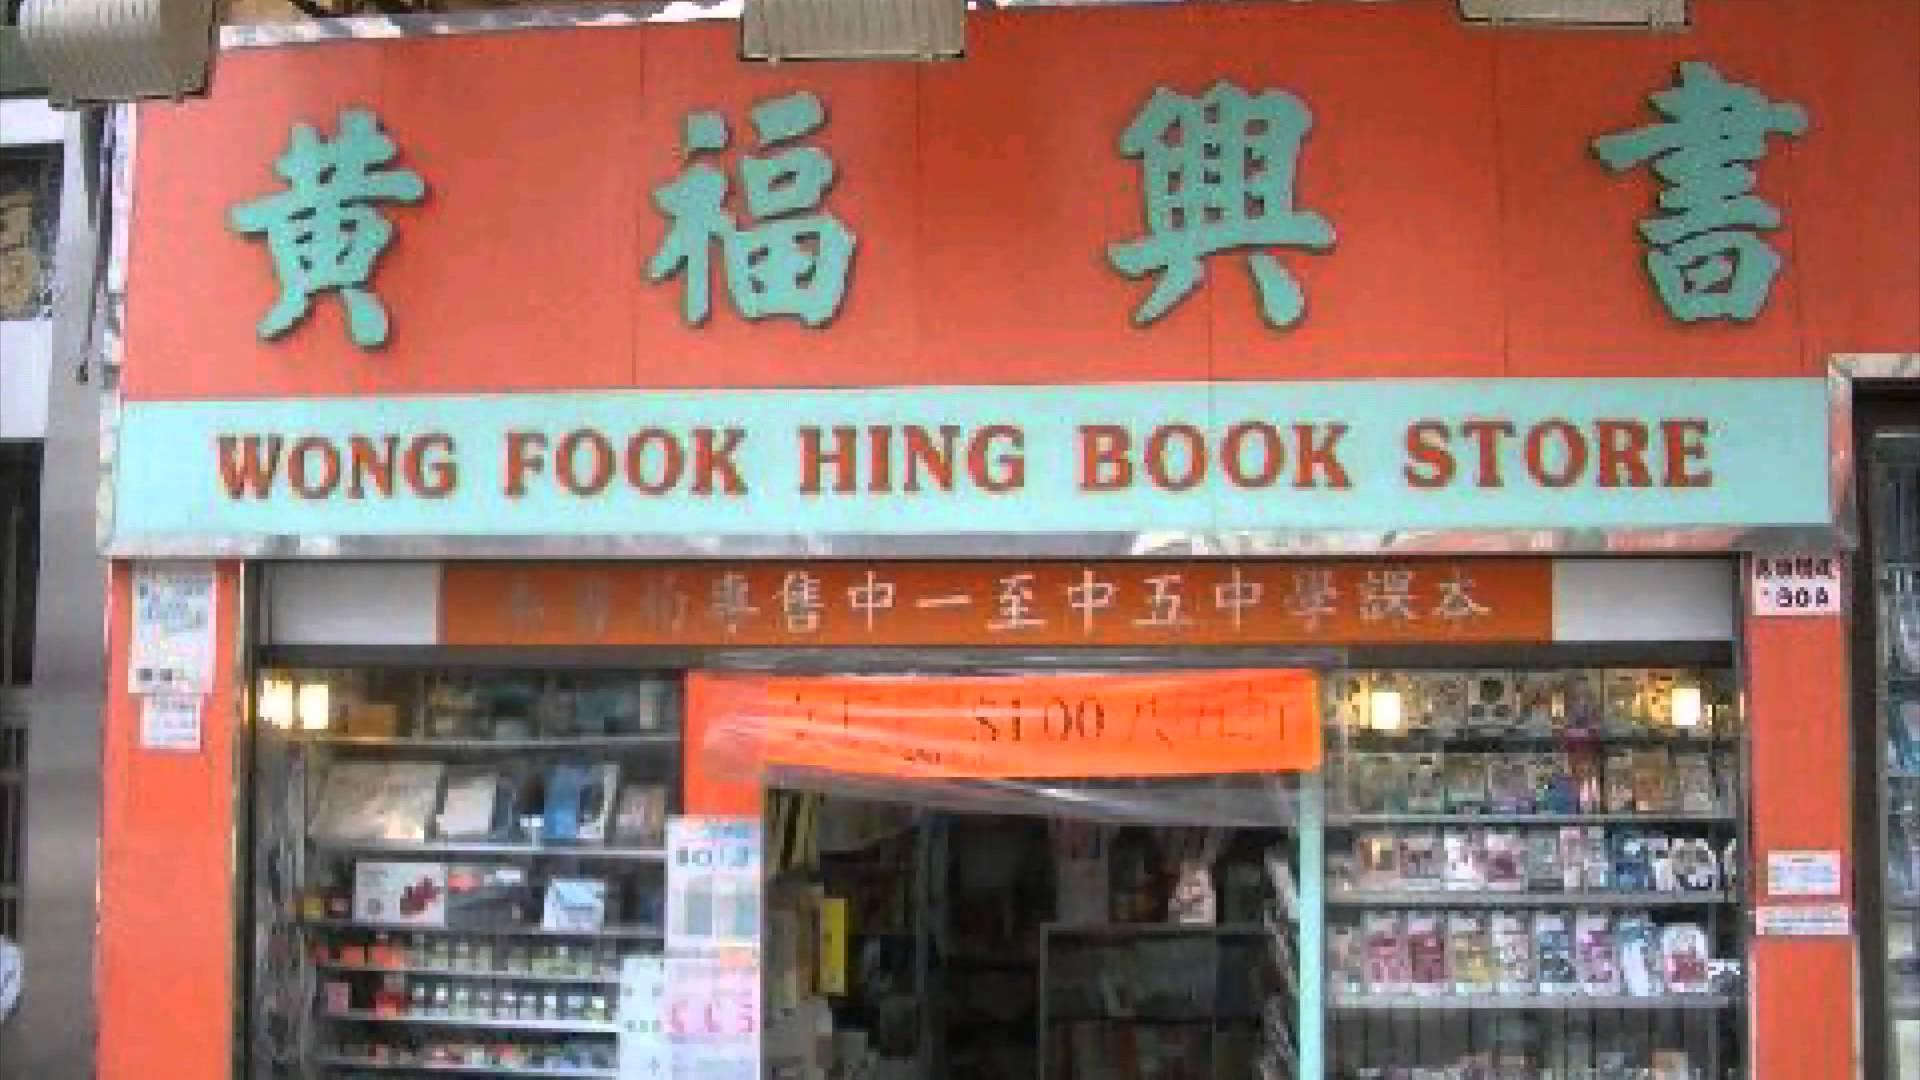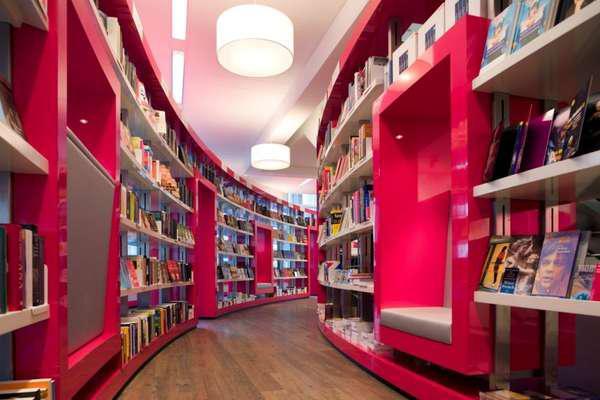The first image is the image on the left, the second image is the image on the right. Analyze the images presented: Is the assertion "there is a bookstore in a brick building with green painted trim on the door and window" valid? Answer yes or no. No. The first image is the image on the left, the second image is the image on the right. Assess this claim about the two images: "The left image depicts a painted red bookshop exterior with some type of awning over its front door and display window.". Correct or not? Answer yes or no. No. 